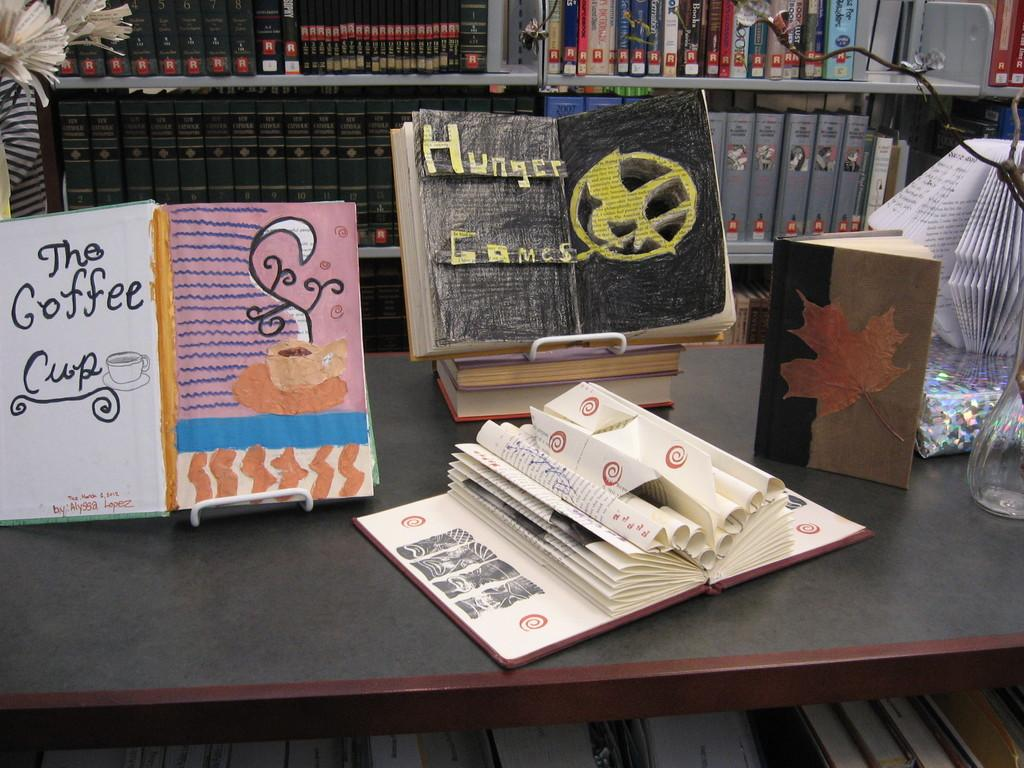<image>
Relay a brief, clear account of the picture shown. The art in the middle is for the series Hunger Games 